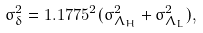Convert formula to latex. <formula><loc_0><loc_0><loc_500><loc_500>\sigma _ { \delta } ^ { 2 } = 1 . 1 7 7 5 ^ { 2 } ( \sigma _ { \Lambda _ { H } } ^ { 2 } + \sigma _ { \Lambda _ { L } } ^ { 2 } ) ,</formula> 